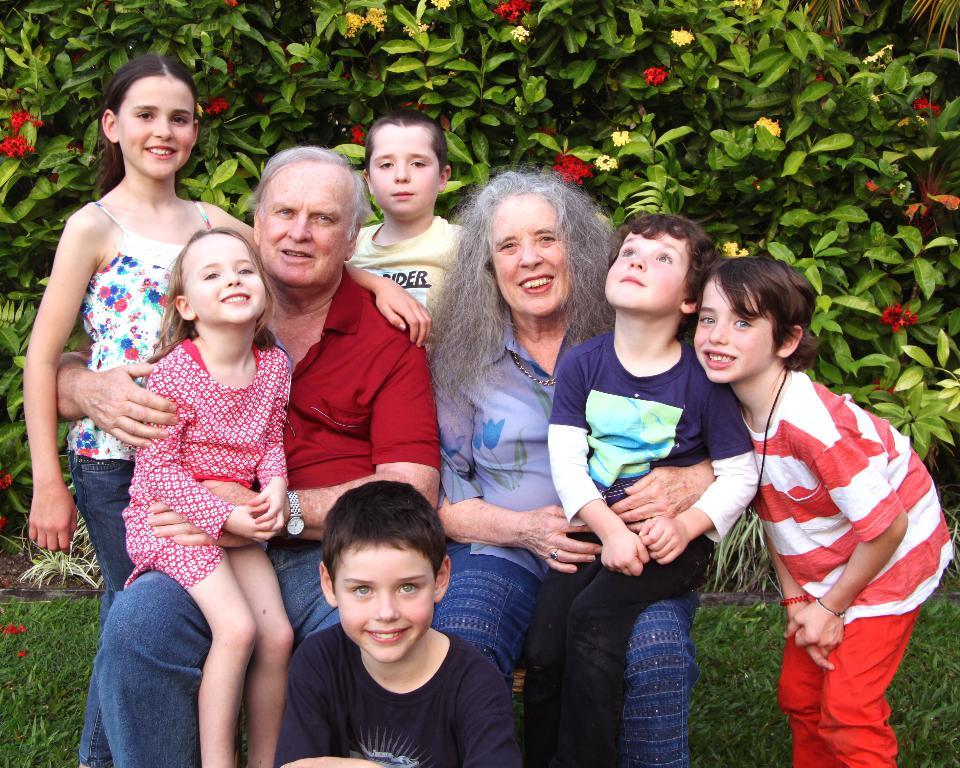How many people are in the image? There are four people in the image: a man, a woman, and two children. What are the man and woman doing in the image? The man and woman are sitting with the children in the image. What can be seen in the background of the image? There are plants with flowers and grass on the ground in the background of the image. What type of metal is the bird made of in the image? There is no bird present in the image, and therefore no metal bird can be observed. 